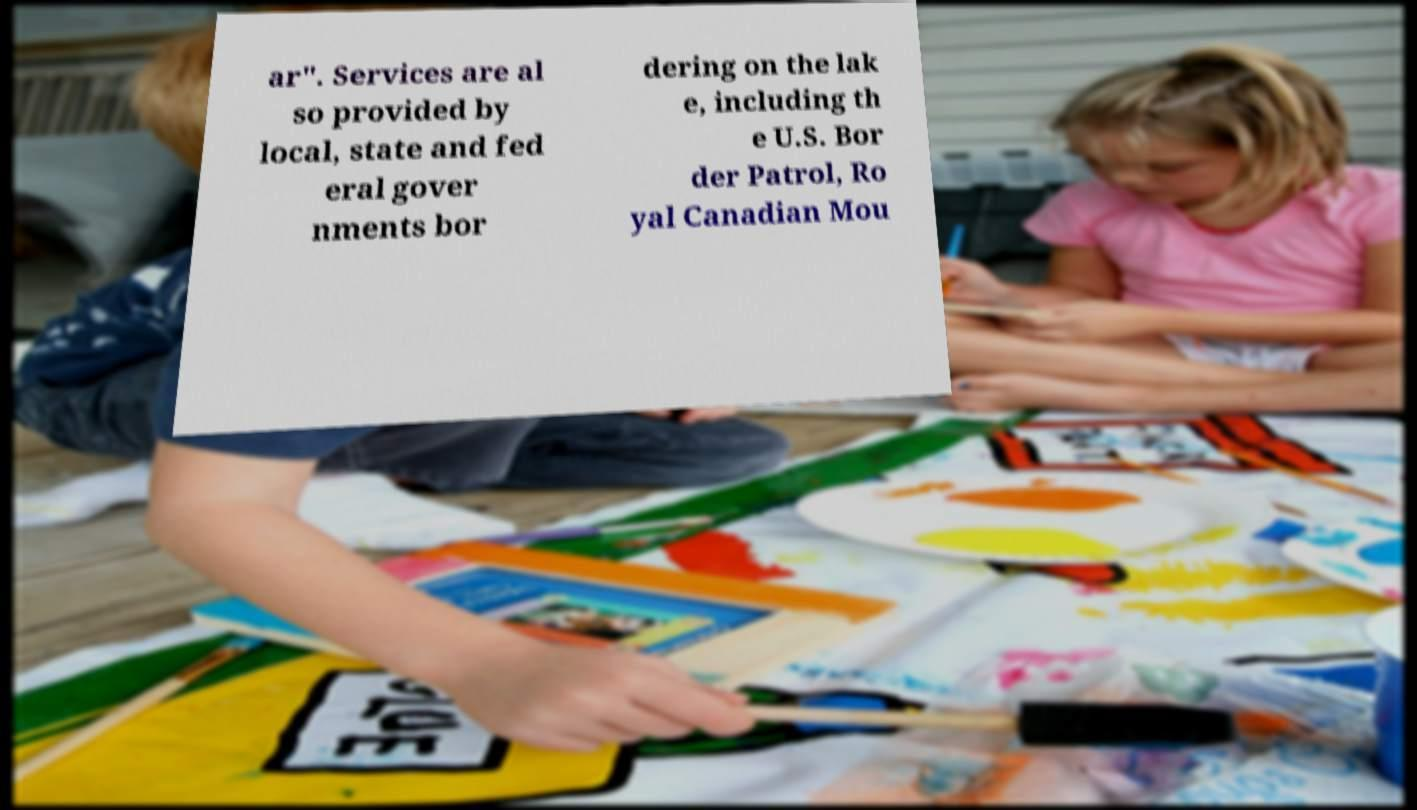I need the written content from this picture converted into text. Can you do that? ar". Services are al so provided by local, state and fed eral gover nments bor dering on the lak e, including th e U.S. Bor der Patrol, Ro yal Canadian Mou 